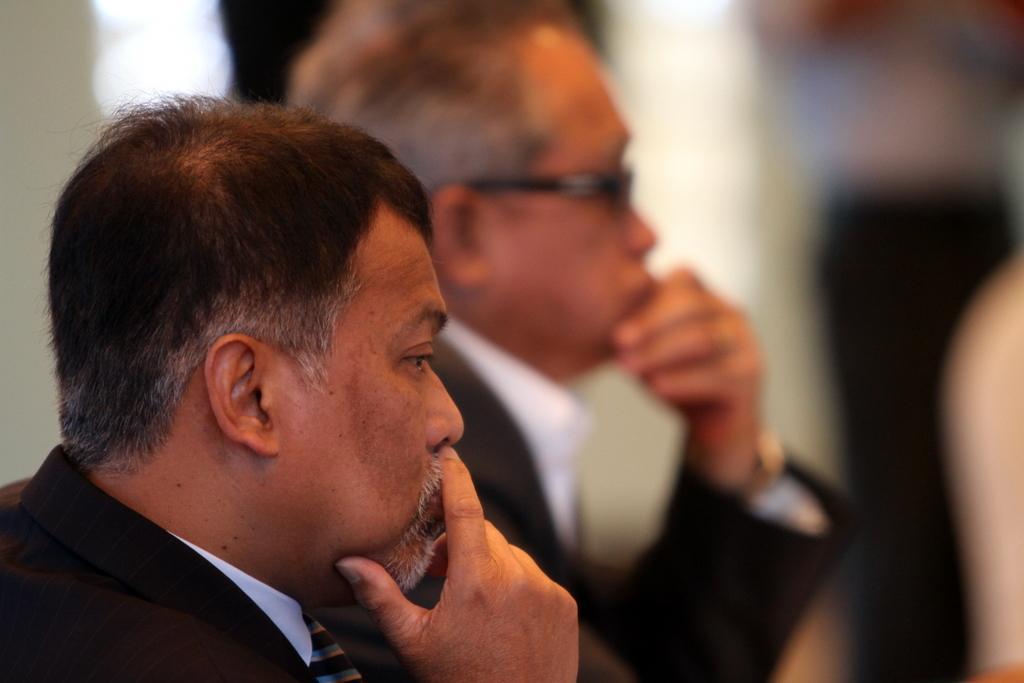Could you give a brief overview of what you see in this image? In this image we can see two persons are there. In the background the image is blur. 